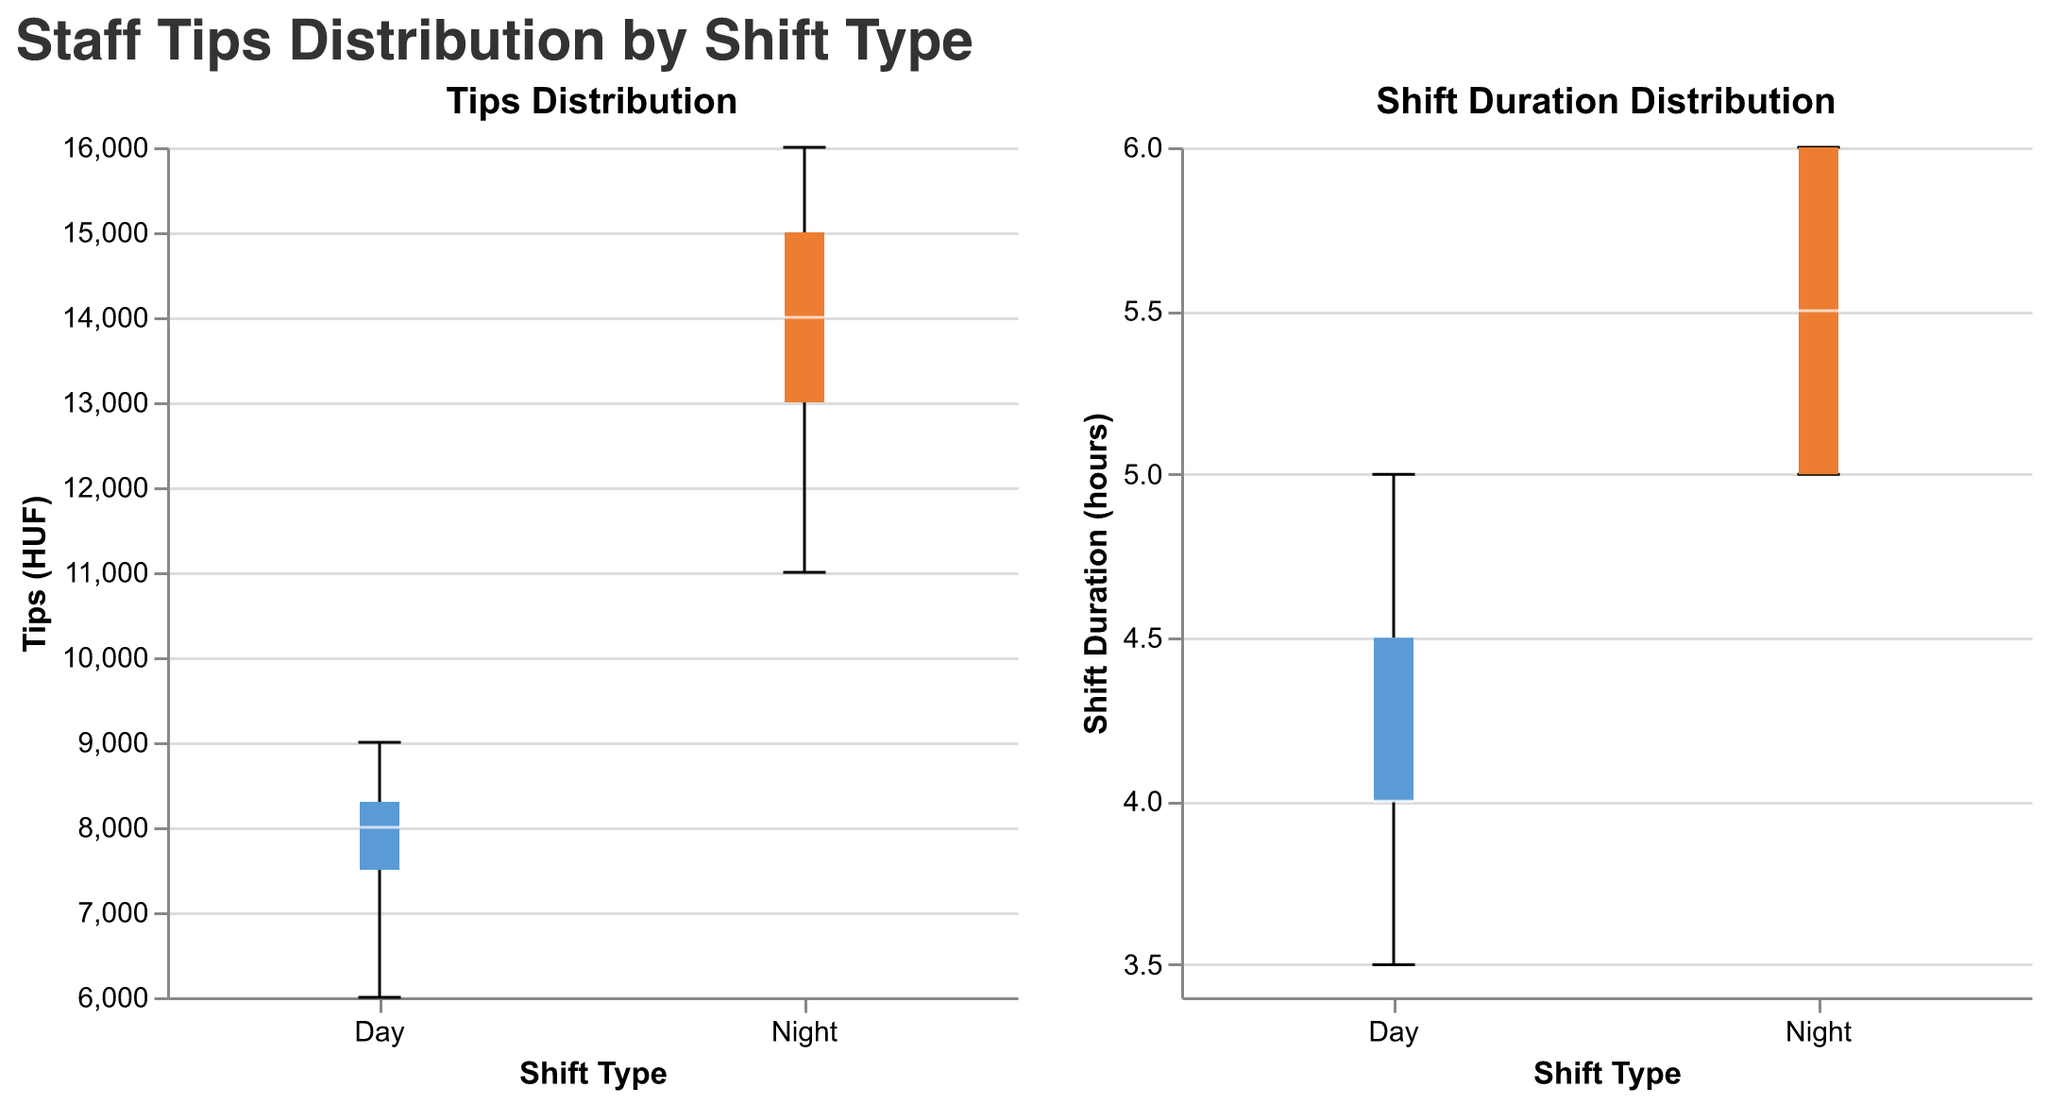What's the title of the left subplot? The title of the left subplot is shown at the top of the left box plot figure. It displays "Tips Distribution".
Answer: Tips Distribution How many different shift types are shown in the plots? The x-axes of both plots display two distinct categories under "Shift Type". These categories are "Day" and "Night".
Answer: 2 Which shift type has a higher median value in Tips? In the left subplot, the box plot for the "Night" shift type has its median line (white line) located higher than the median line of the "Day" shift type, indicating higher median Tips for "Night".
Answer: Night What's the maximum value of Tips for the "Day" shift type? In the left subplot for "Tips Distribution", the upper whisker of the "Day" shift type extends to the maximum value. By examining the plot, this value is around 9000 HUF.
Answer: 9000 HUF Is the shift duration usually longer for the "Night" shift or the "Day" shift? In the right subplot, the box plot for "Night" shifts has both a higher median and higher maximum whisker compared to the "Day" shift plot, indicating longer shift durations for "Night".
Answer: Night What is the interquartile range (IQR) of Tips for the "Day" shift? To find this, look at the box (edges) of the "Day" plot in the "Tips Distribution" subplot. The IQR is the difference between the third quartile (about 8500 HUF) and the first quartile (about 7500 HUF).
Answer: 1000 HUF Between which two values do most of the shift durations lie for the "Day" shift? The "Day" shift box plot in the "Shift Duration Distribution" subplot shows the interquartile range where the upper edge is around 4.5 hours and the lower edge is around 4 hours.
Answer: 4 and 4.5 hours Which plot indicates more variability, the "Tips" plot or the "Shift Duration" plot? To determine this, compare the lengths of the whiskers (which represent range) and the interquartile ranges of both plots. The whiskers in the "Tips Distribution" plot show greater variability than those in the "Shift Duration Distribution" plot.
Answer: Tips Distribution Is there any overlap in the range of Tips values between "Day" and "Night" shifts? By inspecting the whiskers and the box of the left plot, it can be seen that the "Day" shifts range up to around 9000 HUF while the "Night" shifts start just above this value, indicating no overlap.
Answer: No Which shift type shows a greater spread in Shift Duration? In the right subplot for "Shift Duration Distribution", the length of the "Night" box plot indicates a greater spread compared to the "Day" box plot.
Answer: Night 